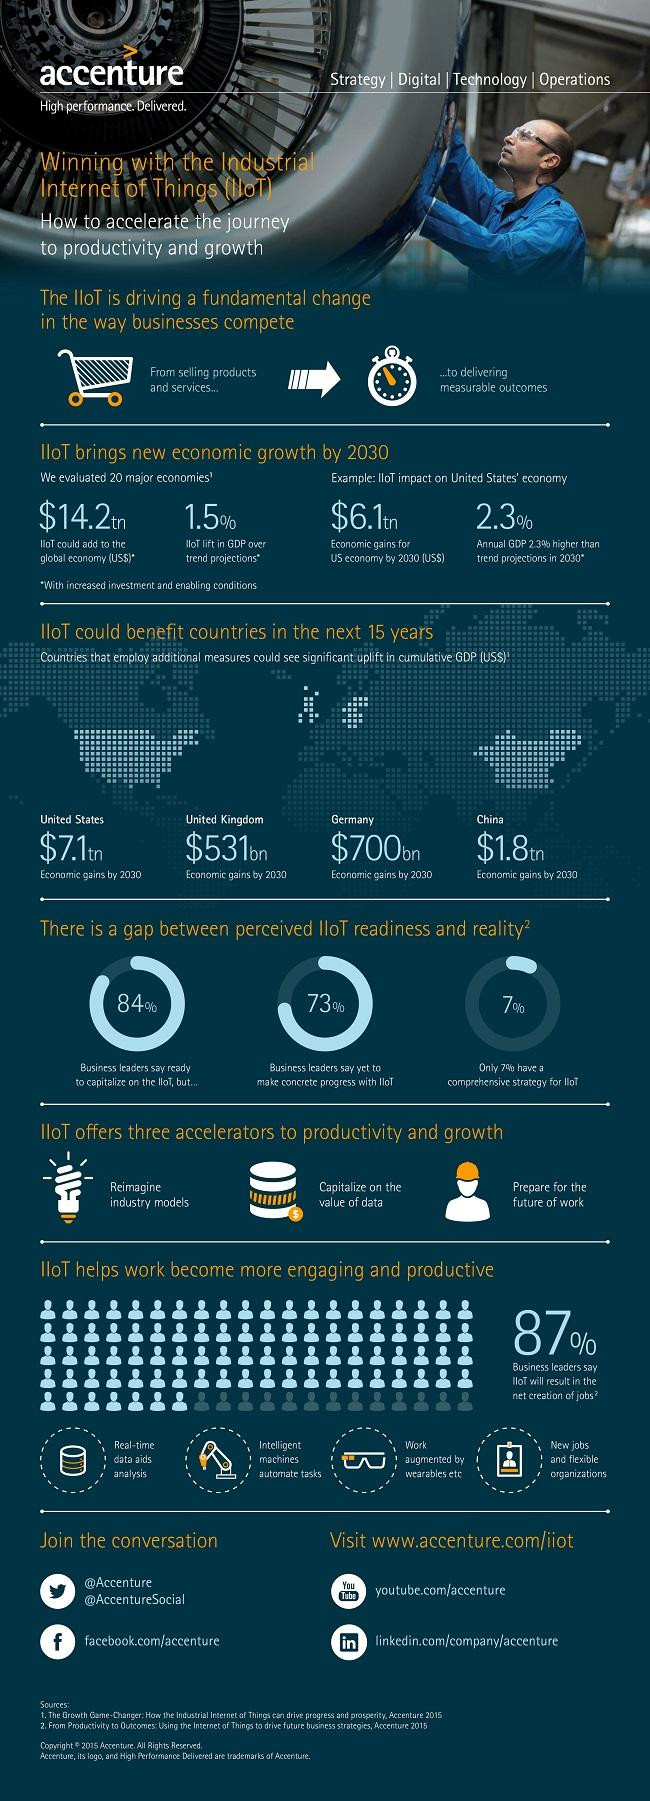Identify some key points in this picture. The economic impact of IIoT on the US economy by 2030 is projected to reach $6.1 trillion. According to a survey of business leaders, 73% have not yet made concrete progress with the Industrial Internet of Things (IIoT). By 2030, China is projected to experience a significant economic gain of $1.8 trillion. According to the survey, only 7% of the business leaders have a comprehensive strategy for the Industrial Internet of Things (IIoT). By 2030, the Industrial Internet of Things (IIoT) is expected to contribute 1.5% to the overall GDP growth. 